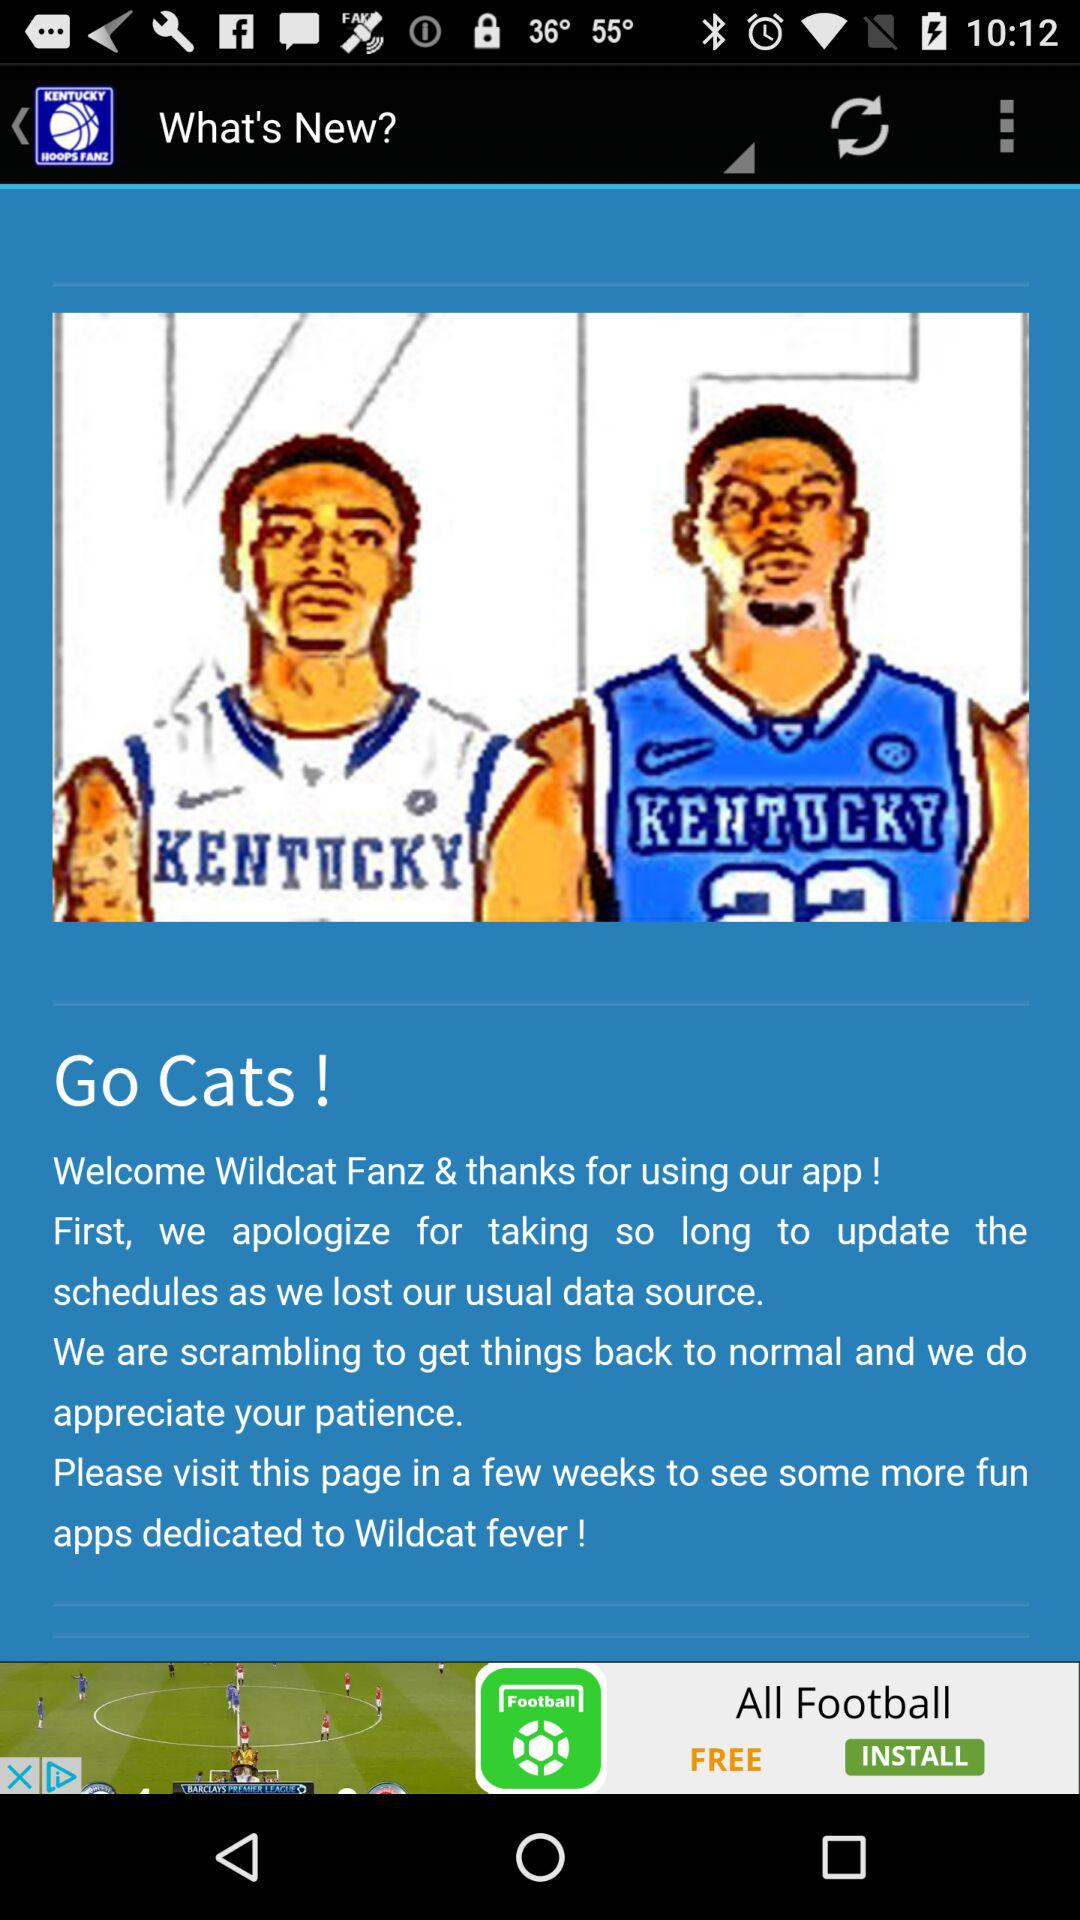What is the name of the application? The name of the application is "Kentucky Basketball UK". 